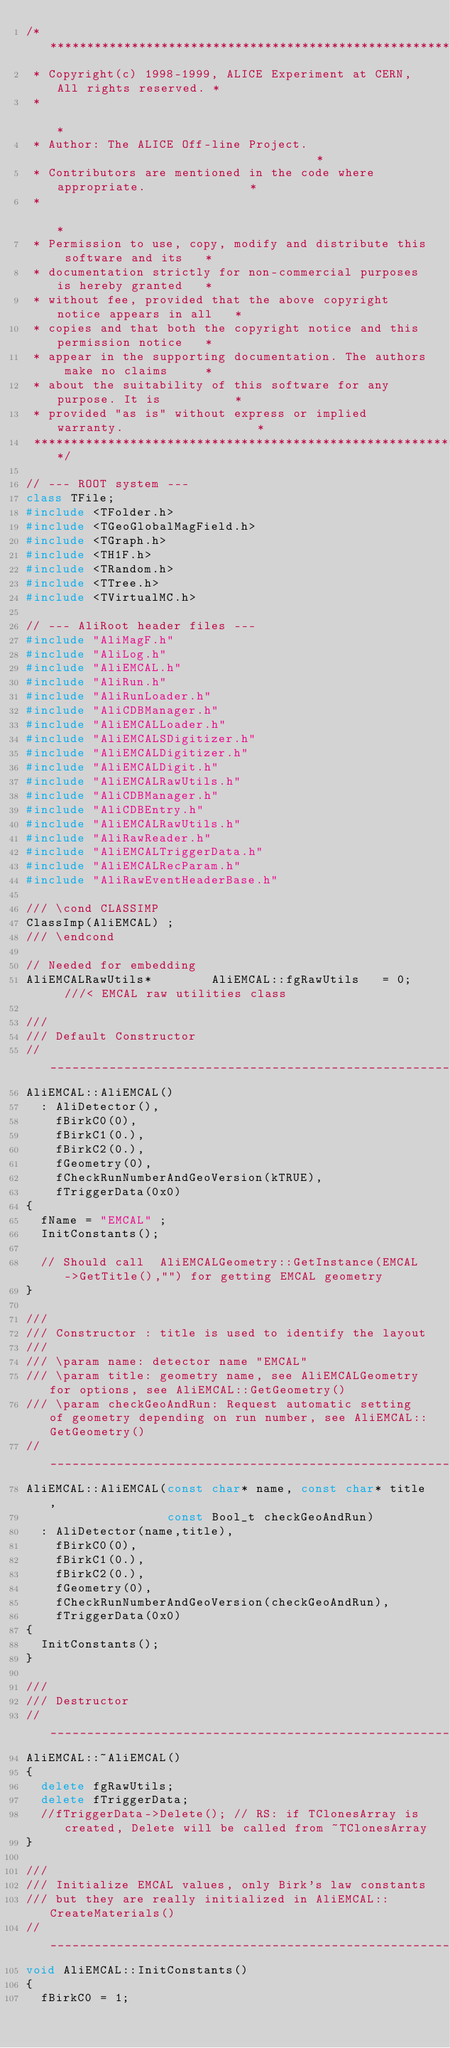Convert code to text. <code><loc_0><loc_0><loc_500><loc_500><_C++_>/**************************************************************************
 * Copyright(c) 1998-1999, ALICE Experiment at CERN, All rights reserved. *
 *                                                                        *
 * Author: The ALICE Off-line Project.                                    *
 * Contributors are mentioned in the code where appropriate.              *
 *                                                                        *
 * Permission to use, copy, modify and distribute this software and its   *
 * documentation strictly for non-commercial purposes is hereby granted   *
 * without fee, provided that the above copyright notice appears in all   *
 * copies and that both the copyright notice and this permission notice   *
 * appear in the supporting documentation. The authors make no claims     *
 * about the suitability of this software for any purpose. It is          *
 * provided "as is" without express or implied warranty.                  *
 **************************************************************************/

// --- ROOT system ---
class TFile;
#include <TFolder.h> 
#include <TGeoGlobalMagField.h>
#include <TGraph.h> 
#include <TH1F.h> 
#include <TRandom.h> 
#include <TTree.h>
#include <TVirtualMC.h> 

// --- AliRoot header files ---
#include "AliMagF.h"
#include "AliLog.h"
#include "AliEMCAL.h"
#include "AliRun.h"
#include "AliRunLoader.h"
#include "AliCDBManager.h"
#include "AliEMCALLoader.h"
#include "AliEMCALSDigitizer.h"
#include "AliEMCALDigitizer.h"
#include "AliEMCALDigit.h"
#include "AliEMCALRawUtils.h"
#include "AliCDBManager.h"
#include "AliCDBEntry.h"
#include "AliEMCALRawUtils.h"
#include "AliRawReader.h"
#include "AliEMCALTriggerData.h"
#include "AliEMCALRecParam.h"
#include "AliRawEventHeaderBase.h"

/// \cond CLASSIMP
ClassImp(AliEMCAL) ;
/// \endcond

// Needed for embedding
AliEMCALRawUtils*        AliEMCAL::fgRawUtils   = 0;   ///< EMCAL raw utilities class

///
/// Default Constructor
//____________________________________________________________________________
AliEMCAL::AliEMCAL()
  : AliDetector(),
    fBirkC0(0),
    fBirkC1(0.),
    fBirkC2(0.),
    fGeometry(0), 
    fCheckRunNumberAndGeoVersion(kTRUE),
    fTriggerData(0x0)
{
  fName = "EMCAL" ;
  InitConstants();
  
  // Should call  AliEMCALGeometry::GetInstance(EMCAL->GetTitle(),"") for getting EMCAL geometry
}

///
/// Constructor : title is used to identify the layout
/// 
/// \param name: detector name "EMCAL"
/// \param title: geometry name, see AliEMCALGeometry for options, see AliEMCAL::GetGeometry()
/// \param checkGeoAndRun: Request automatic setting of geometry depending on run number, see AliEMCAL::GetGeometry()
//____________________________________________________________________________
AliEMCAL::AliEMCAL(const char* name, const char* title, 
                   const Bool_t checkGeoAndRun)
  : AliDetector(name,title),
    fBirkC0(0),
    fBirkC1(0.),
    fBirkC2(0.),
    fGeometry(0), 
    fCheckRunNumberAndGeoVersion(checkGeoAndRun),
    fTriggerData(0x0)
{
  InitConstants();  
}

///
/// Destructor
//____________________________________________________________________________
AliEMCAL::~AliEMCAL()
{
  delete fgRawUtils;
  delete fTriggerData;   
  //fTriggerData->Delete(); // RS: if TClonesArray is created, Delete will be called from ~TClonesArray
}

///
/// Initialize EMCAL values, only Birk's law constants
/// but they are really initialized in AliEMCAL::CreateMaterials()
//____________________________________________________________________________
void AliEMCAL::InitConstants()
{
  fBirkC0 = 1;</code> 